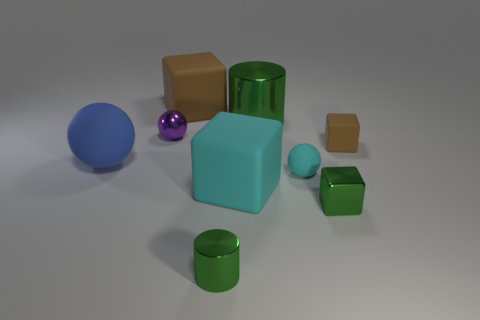Does the large object left of the big brown matte thing have the same material as the small cylinder that is in front of the large cyan matte object?
Keep it short and to the point. No. What number of big things are either cyan metallic blocks or cyan rubber blocks?
Ensure brevity in your answer.  1. There is a big green object that is made of the same material as the small purple object; what shape is it?
Keep it short and to the point. Cylinder. Are there fewer tiny green things on the left side of the blue ball than tiny cyan cylinders?
Your answer should be very brief. No. Do the big brown matte object and the big cyan rubber thing have the same shape?
Your answer should be very brief. Yes. How many shiny things are either big blocks or tiny green cylinders?
Your answer should be compact. 1. Are there any rubber things that have the same size as the purple metallic sphere?
Make the answer very short. Yes. The big thing that is the same color as the metal cube is what shape?
Keep it short and to the point. Cylinder. What number of purple metal objects are the same size as the green cube?
Provide a succinct answer. 1. Is the size of the matte cube in front of the large blue rubber object the same as the cylinder that is behind the cyan cube?
Provide a short and direct response. Yes. 